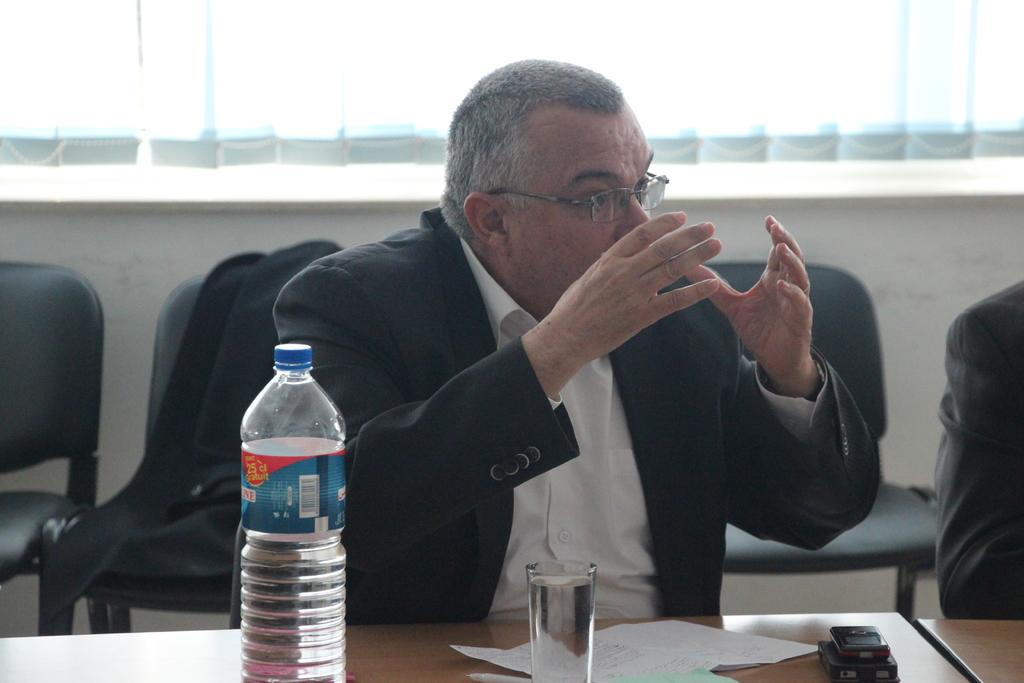What is the man in the image doing? The man is sitting on a chair and speaking. What is the man wearing? The man is wearing a suit. What objects can be seen on the table in the image? There is a bottle, a glass of water, a paper, and mobile phones on the table. What type of table is in the image? The table is made of wood. Where is the kettle located in the image? There is no kettle present in the image. What type of glue is being used by the man in the image? The man is speaking, not using glue, and there is no glue present in the image. 